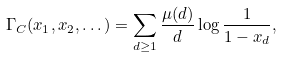Convert formula to latex. <formula><loc_0><loc_0><loc_500><loc_500>\Gamma _ { C } ( x _ { 1 } , x _ { 2 } , \dots ) = \sum _ { d \geq 1 } \frac { \mu ( d ) } { d } \log { \frac { 1 } { 1 - x _ { d } } } ,</formula> 